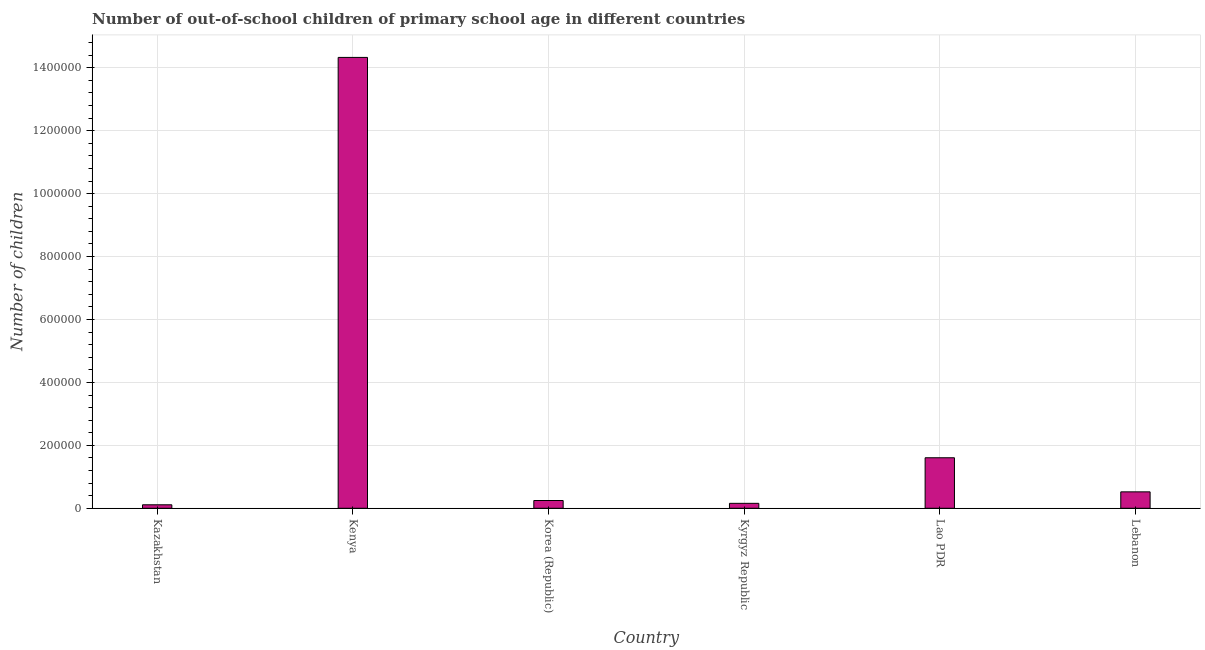Does the graph contain any zero values?
Provide a succinct answer. No. What is the title of the graph?
Your answer should be very brief. Number of out-of-school children of primary school age in different countries. What is the label or title of the X-axis?
Ensure brevity in your answer.  Country. What is the label or title of the Y-axis?
Offer a very short reply. Number of children. What is the number of out-of-school children in Kenya?
Your answer should be very brief. 1.43e+06. Across all countries, what is the maximum number of out-of-school children?
Your answer should be very brief. 1.43e+06. Across all countries, what is the minimum number of out-of-school children?
Offer a terse response. 1.10e+04. In which country was the number of out-of-school children maximum?
Your answer should be very brief. Kenya. In which country was the number of out-of-school children minimum?
Keep it short and to the point. Kazakhstan. What is the sum of the number of out-of-school children?
Your response must be concise. 1.70e+06. What is the difference between the number of out-of-school children in Korea (Republic) and Kyrgyz Republic?
Keep it short and to the point. 8972. What is the average number of out-of-school children per country?
Your response must be concise. 2.83e+05. What is the median number of out-of-school children?
Your answer should be compact. 3.84e+04. What is the ratio of the number of out-of-school children in Kenya to that in Korea (Republic)?
Offer a terse response. 58.12. Is the difference between the number of out-of-school children in Kenya and Kyrgyz Republic greater than the difference between any two countries?
Offer a terse response. No. What is the difference between the highest and the second highest number of out-of-school children?
Your answer should be compact. 1.27e+06. Is the sum of the number of out-of-school children in Lao PDR and Lebanon greater than the maximum number of out-of-school children across all countries?
Provide a short and direct response. No. What is the difference between the highest and the lowest number of out-of-school children?
Make the answer very short. 1.42e+06. In how many countries, is the number of out-of-school children greater than the average number of out-of-school children taken over all countries?
Your answer should be very brief. 1. Are all the bars in the graph horizontal?
Provide a succinct answer. No. How many countries are there in the graph?
Keep it short and to the point. 6. What is the Number of children of Kazakhstan?
Keep it short and to the point. 1.10e+04. What is the Number of children of Kenya?
Make the answer very short. 1.43e+06. What is the Number of children in Korea (Republic)?
Your answer should be compact. 2.47e+04. What is the Number of children in Kyrgyz Republic?
Your answer should be compact. 1.57e+04. What is the Number of children in Lao PDR?
Provide a short and direct response. 1.61e+05. What is the Number of children in Lebanon?
Provide a succinct answer. 5.22e+04. What is the difference between the Number of children in Kazakhstan and Kenya?
Give a very brief answer. -1.42e+06. What is the difference between the Number of children in Kazakhstan and Korea (Republic)?
Offer a very short reply. -1.36e+04. What is the difference between the Number of children in Kazakhstan and Kyrgyz Republic?
Offer a very short reply. -4640. What is the difference between the Number of children in Kazakhstan and Lao PDR?
Ensure brevity in your answer.  -1.49e+05. What is the difference between the Number of children in Kazakhstan and Lebanon?
Offer a very short reply. -4.11e+04. What is the difference between the Number of children in Kenya and Korea (Republic)?
Give a very brief answer. 1.41e+06. What is the difference between the Number of children in Kenya and Kyrgyz Republic?
Ensure brevity in your answer.  1.42e+06. What is the difference between the Number of children in Kenya and Lao PDR?
Offer a very short reply. 1.27e+06. What is the difference between the Number of children in Kenya and Lebanon?
Make the answer very short. 1.38e+06. What is the difference between the Number of children in Korea (Republic) and Kyrgyz Republic?
Your answer should be compact. 8972. What is the difference between the Number of children in Korea (Republic) and Lao PDR?
Make the answer very short. -1.36e+05. What is the difference between the Number of children in Korea (Republic) and Lebanon?
Keep it short and to the point. -2.75e+04. What is the difference between the Number of children in Kyrgyz Republic and Lao PDR?
Keep it short and to the point. -1.45e+05. What is the difference between the Number of children in Kyrgyz Republic and Lebanon?
Your answer should be compact. -3.65e+04. What is the difference between the Number of children in Lao PDR and Lebanon?
Keep it short and to the point. 1.08e+05. What is the ratio of the Number of children in Kazakhstan to that in Kenya?
Make the answer very short. 0.01. What is the ratio of the Number of children in Kazakhstan to that in Korea (Republic)?
Keep it short and to the point. 0.45. What is the ratio of the Number of children in Kazakhstan to that in Kyrgyz Republic?
Provide a short and direct response. 0.7. What is the ratio of the Number of children in Kazakhstan to that in Lao PDR?
Offer a terse response. 0.07. What is the ratio of the Number of children in Kazakhstan to that in Lebanon?
Ensure brevity in your answer.  0.21. What is the ratio of the Number of children in Kenya to that in Korea (Republic)?
Make the answer very short. 58.12. What is the ratio of the Number of children in Kenya to that in Kyrgyz Republic?
Make the answer very short. 91.36. What is the ratio of the Number of children in Kenya to that in Lao PDR?
Your answer should be compact. 8.93. What is the ratio of the Number of children in Kenya to that in Lebanon?
Provide a short and direct response. 27.46. What is the ratio of the Number of children in Korea (Republic) to that in Kyrgyz Republic?
Give a very brief answer. 1.57. What is the ratio of the Number of children in Korea (Republic) to that in Lao PDR?
Provide a succinct answer. 0.15. What is the ratio of the Number of children in Korea (Republic) to that in Lebanon?
Your response must be concise. 0.47. What is the ratio of the Number of children in Kyrgyz Republic to that in Lao PDR?
Make the answer very short. 0.1. What is the ratio of the Number of children in Kyrgyz Republic to that in Lebanon?
Offer a very short reply. 0.3. What is the ratio of the Number of children in Lao PDR to that in Lebanon?
Your answer should be very brief. 3.08. 